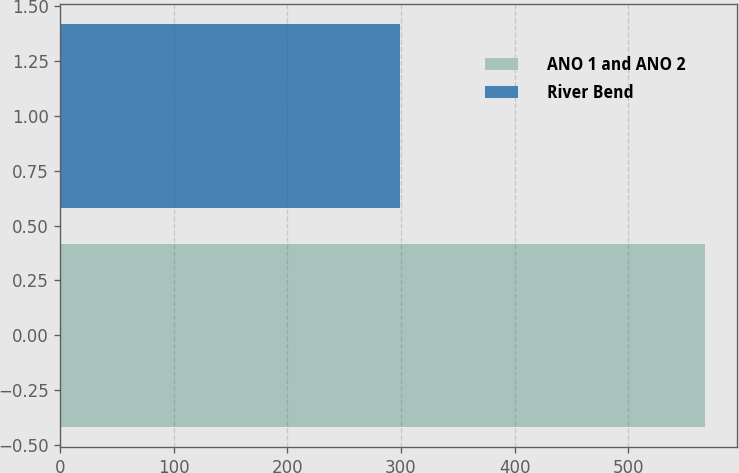Convert chart. <chart><loc_0><loc_0><loc_500><loc_500><bar_chart><fcel>ANO 1 and ANO 2<fcel>River Bend<nl><fcel>567.5<fcel>298.8<nl></chart> 